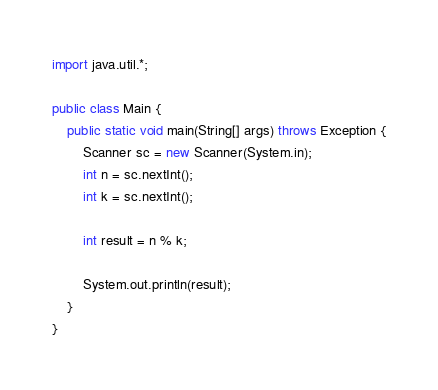<code> <loc_0><loc_0><loc_500><loc_500><_Java_>import java.util.*;

public class Main {
    public static void main(String[] args) throws Exception {
        Scanner sc = new Scanner(System.in);
        int n = sc.nextInt();
        int k = sc.nextInt();
        
        int result = n % k;

        System.out.println(result);
    }
}
</code> 